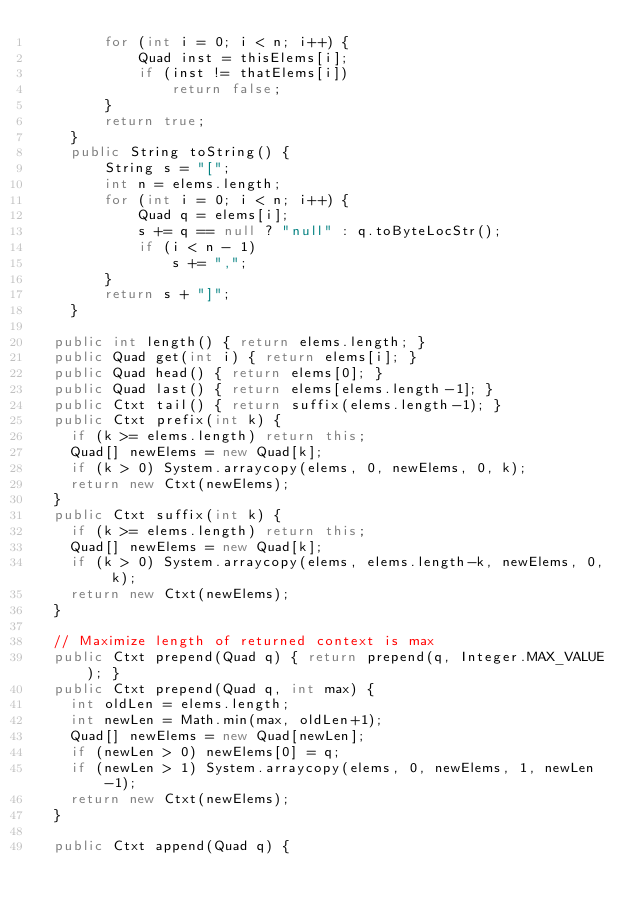<code> <loc_0><loc_0><loc_500><loc_500><_Java_>        for (int i = 0; i < n; i++) {
            Quad inst = thisElems[i];
            if (inst != thatElems[i])
                return false;
        }
        return true;
    }
    public String toString() {
        String s = "[";
        int n = elems.length;
        for (int i = 0; i < n; i++) {
            Quad q = elems[i];
            s += q == null ? "null" : q.toByteLocStr();
            if (i < n - 1)
                s += ",";
        }
        return s + "]";
    }

  public int length() { return elems.length; }
  public Quad get(int i) { return elems[i]; }
  public Quad head() { return elems[0]; }
  public Quad last() { return elems[elems.length-1]; }
  public Ctxt tail() { return suffix(elems.length-1); }
  public Ctxt prefix(int k) {
    if (k >= elems.length) return this;
    Quad[] newElems = new Quad[k];
    if (k > 0) System.arraycopy(elems, 0, newElems, 0, k);
    return new Ctxt(newElems);
  }
  public Ctxt suffix(int k) {
    if (k >= elems.length) return this;
    Quad[] newElems = new Quad[k];
    if (k > 0) System.arraycopy(elems, elems.length-k, newElems, 0, k);
    return new Ctxt(newElems);
  }

  // Maximize length of returned context is max
  public Ctxt prepend(Quad q) { return prepend(q, Integer.MAX_VALUE); }
  public Ctxt prepend(Quad q, int max) {
    int oldLen = elems.length;
    int newLen = Math.min(max, oldLen+1);
    Quad[] newElems = new Quad[newLen];
    if (newLen > 0) newElems[0] = q;
    if (newLen > 1) System.arraycopy(elems, 0, newElems, 1, newLen-1);
    return new Ctxt(newElems);
  }

  public Ctxt append(Quad q) {</code> 